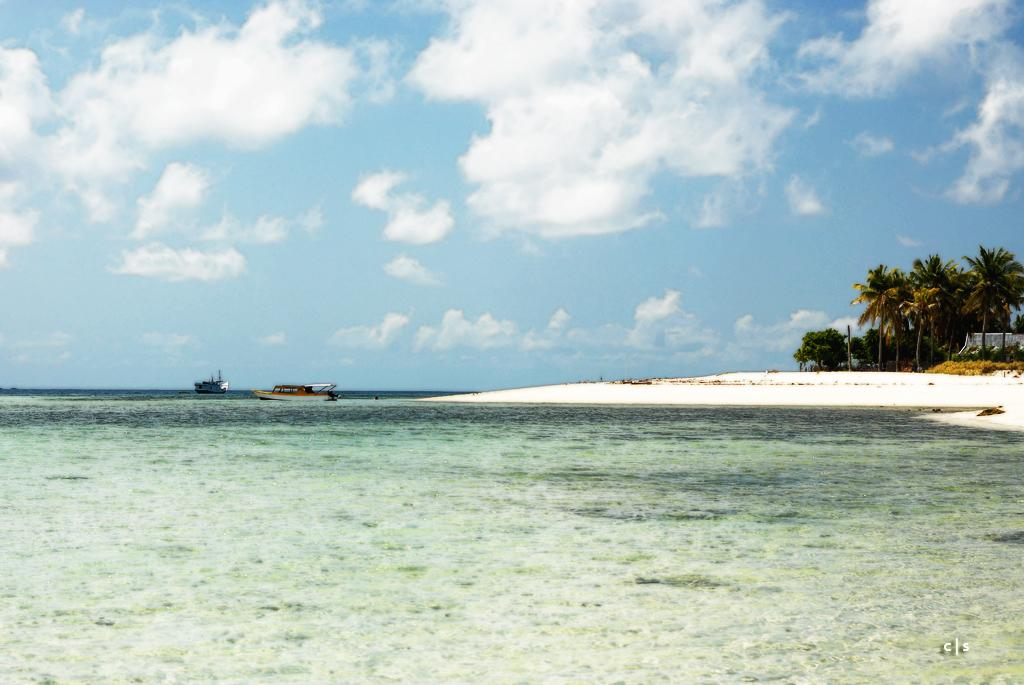What is the primary element visible in the image? There is water in the image. What else can be seen besides the water? There is ground visible in the image, as well as trees and boats on the surface of the water. What is visible in the background of the image? The sky is visible in the background of the image. What type of juice can be seen flowing from the trees in the image? There is no juice flowing from the trees in the image; it features water, ground, trees, boats, and the sky. 